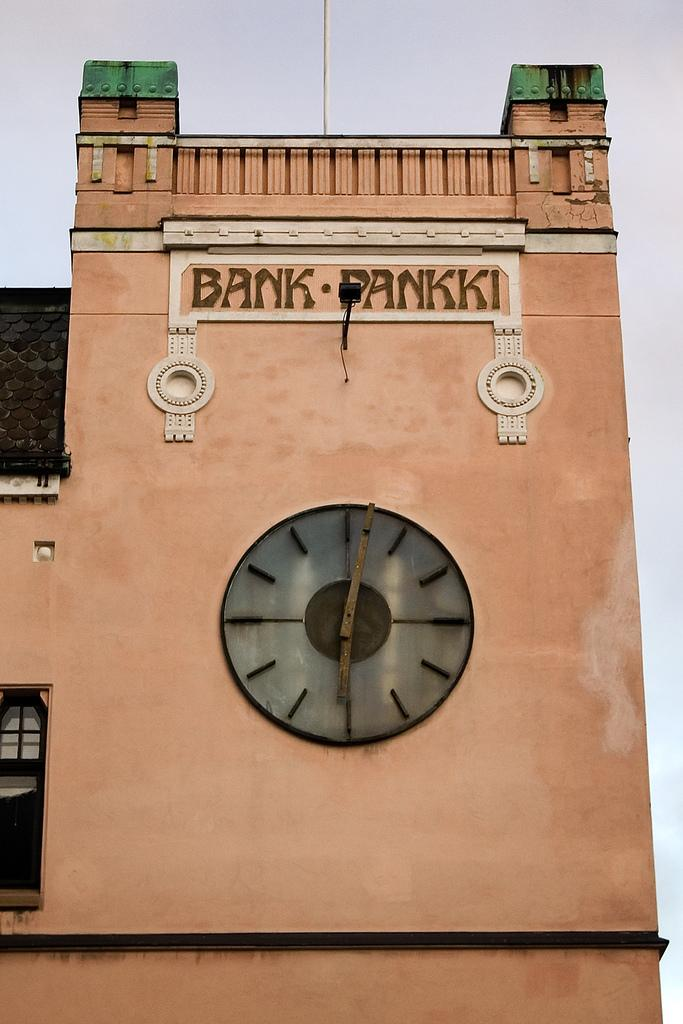Provide a one-sentence caption for the provided image. A clock tower attached to the bank of Pankki. 